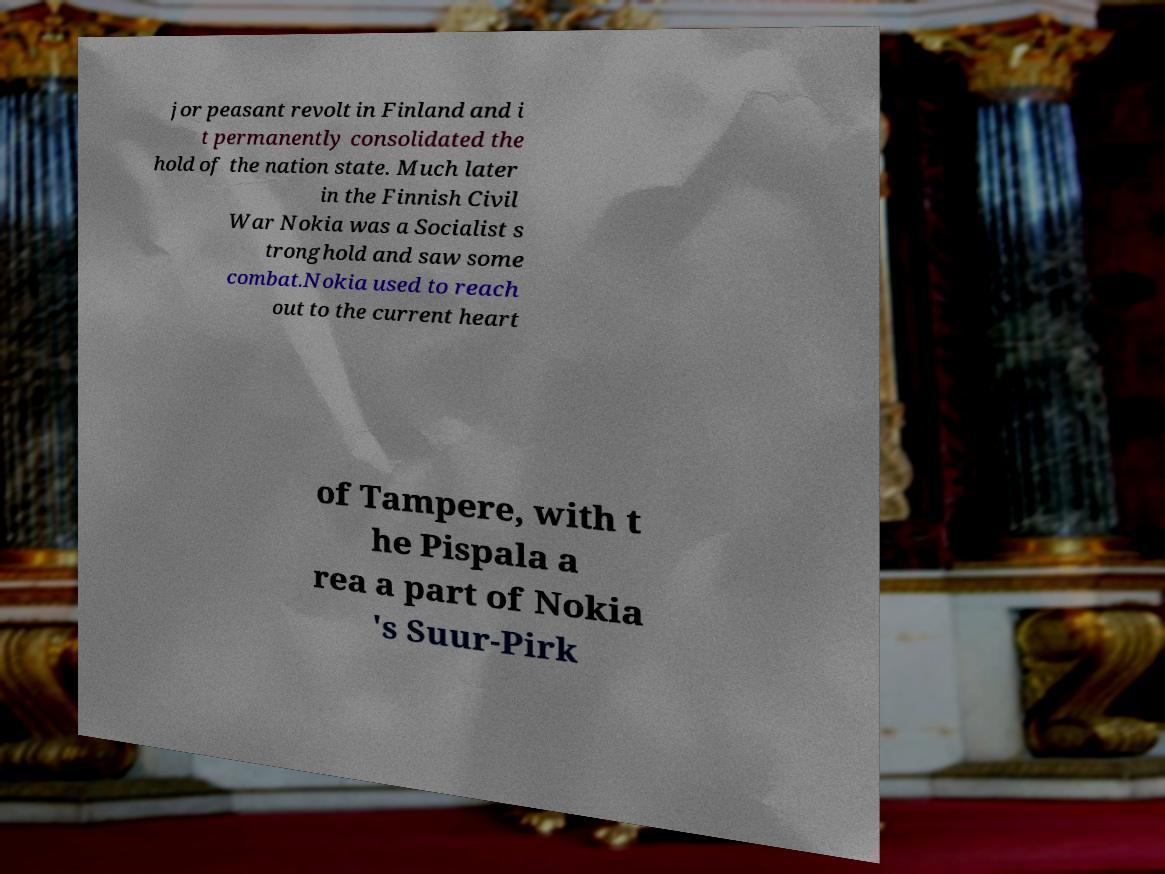For documentation purposes, I need the text within this image transcribed. Could you provide that? jor peasant revolt in Finland and i t permanently consolidated the hold of the nation state. Much later in the Finnish Civil War Nokia was a Socialist s tronghold and saw some combat.Nokia used to reach out to the current heart of Tampere, with t he Pispala a rea a part of Nokia 's Suur-Pirk 